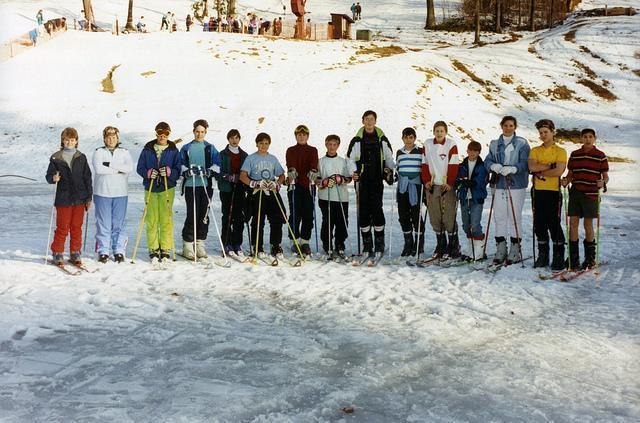How many people are in the photo?
Give a very brief answer. 14. 